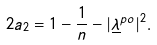<formula> <loc_0><loc_0><loc_500><loc_500>2 a _ { 2 } = 1 - \frac { 1 } { n } - | \underline { \lambda } ^ { p o } | ^ { 2 } .</formula> 